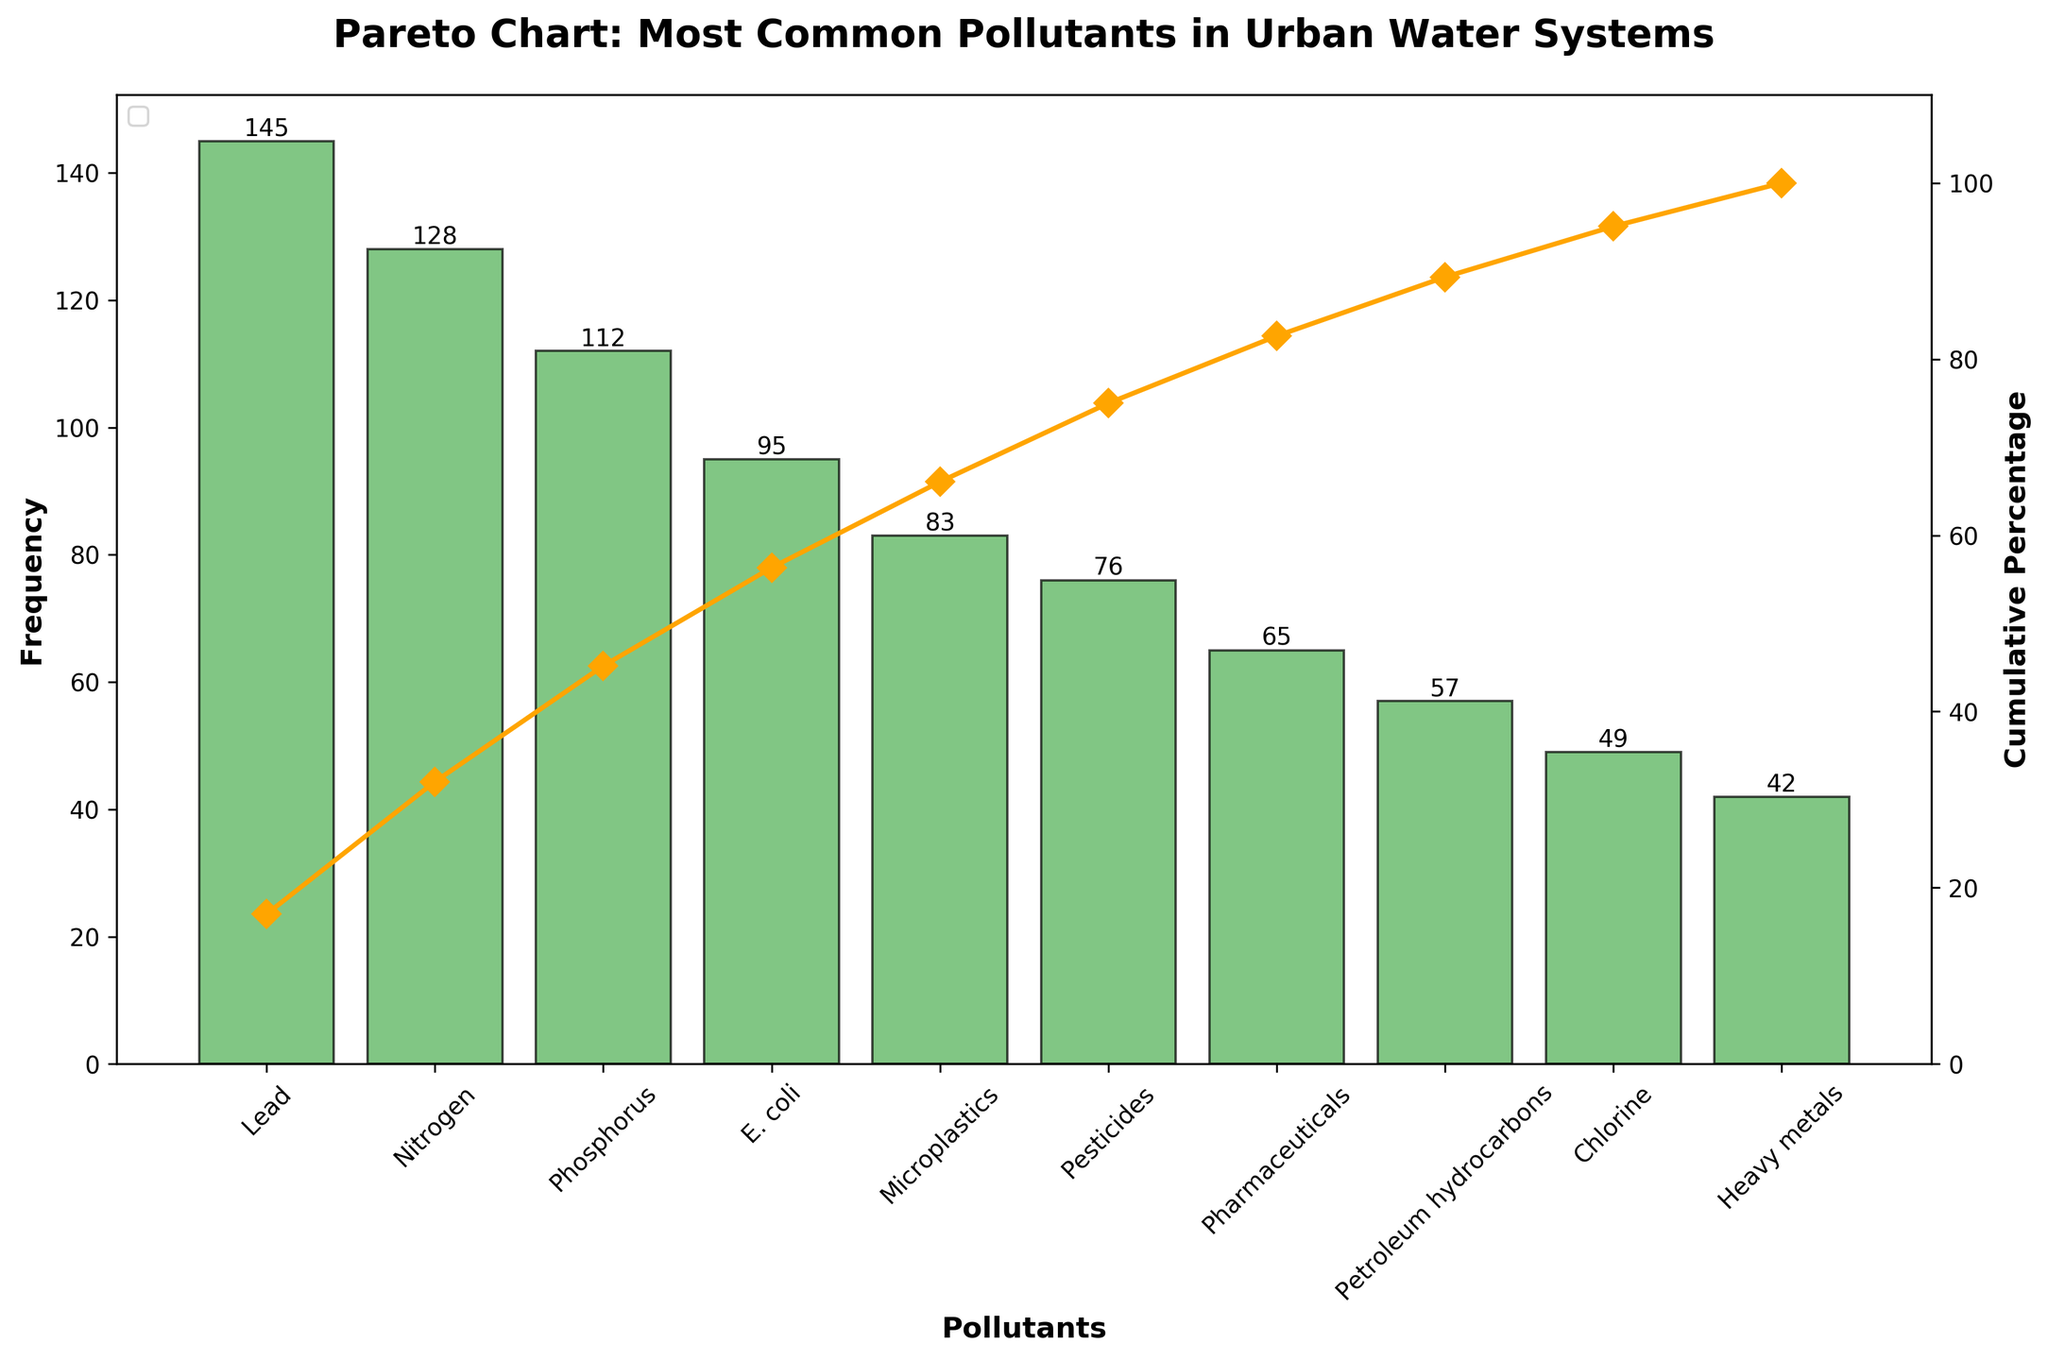What's the title of the figure? The title of the figure is typically displayed at the top and provides a concise description of the chart's content. In this case, it reads "Pareto Chart: Most Common Pollutants in Urban Water Systems."
Answer: Pareto Chart: Most Common Pollutants in Urban Water Systems What's the pollutant with the highest frequency? By looking at the bar chart, the tallest bar represents the pollutant with the highest frequency. The label at the base of this bar indicates that the pollutant is Lead.
Answer: Lead What's the cumulative percentage for the third most common pollutant? The third tallest bar represents the third most common pollutant, which is Phosphorus. Following the corresponding line on the secondary y-axis for cumulative percentage, it shows approximately 64%.
Answer: Approximately 64% What's the combined frequency of Lead, Nitrogen, and Phosphorus? Lead has a frequency of 145, Nitrogen has 128, and Phosphorus has 112. Adding these together: 145 + 128 + 112 = 385.
Answer: 385 Which pollutants have a cumulative percentage greater than 50%? Observing the cumulative percentage line, pollutants that contribute to a cumulative percentage greater than 50% include Lead, Nitrogen, and Phosphorus.
Answer: Lead, Nitrogen, and Phosphorus How many pollutants have a frequency less than 100? Bars with heights lower than 100 correspond to the pollutants E. coli, Microplastics, Pesticides, Pharmaceuticals, Petroleum hydrocarbons, Chlorine, and Heavy metals. Counting these bars, there are 7 pollutants.
Answer: 7 Which pollutant falls exactly at a cumulative percentage of 90%? By tracing the cumulative percentage curve to 90%, we see that it aligns vertically above Pharmaceuticals. This means Pharmaceuticals is the pollutant where the cumulative percentage reaches 90%.
Answer: Pharmaceuticals Is Chlorine or Heavy metals more frequently found in urban water systems? Comparing the heights of the bars for Chlorine and Heavy metals, the Chlorine bar is taller, indicating it has a higher frequency.
Answer: Chlorine Is E. coli one of the top three most common pollutants? The top three bars represent Lead, Nitrogen, and Phosphorus. E. coli does not fall among these, so it is not one of the top three pollutants.
Answer: No What's the frequency difference between the most and the least common pollutants? The most common pollutant, Lead, has a frequency of 145. The least common pollutant, Heavy metals, has a frequency of 42. The difference is 145 - 42 = 103.
Answer: 103 